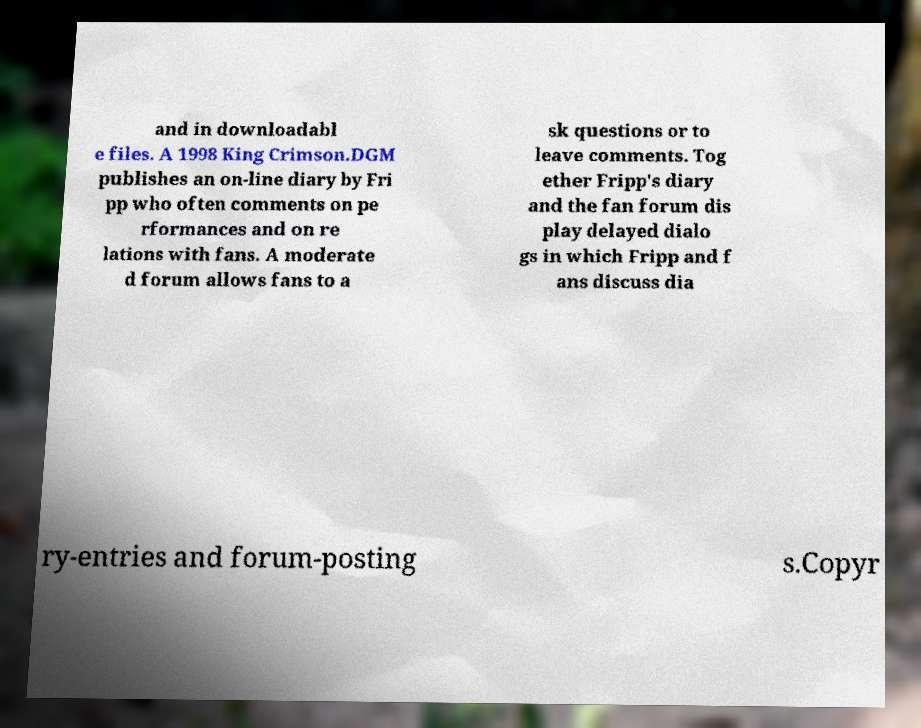Could you extract and type out the text from this image? and in downloadabl e files. A 1998 King Crimson.DGM publishes an on-line diary by Fri pp who often comments on pe rformances and on re lations with fans. A moderate d forum allows fans to a sk questions or to leave comments. Tog ether Fripp's diary and the fan forum dis play delayed dialo gs in which Fripp and f ans discuss dia ry-entries and forum-posting s.Copyr 